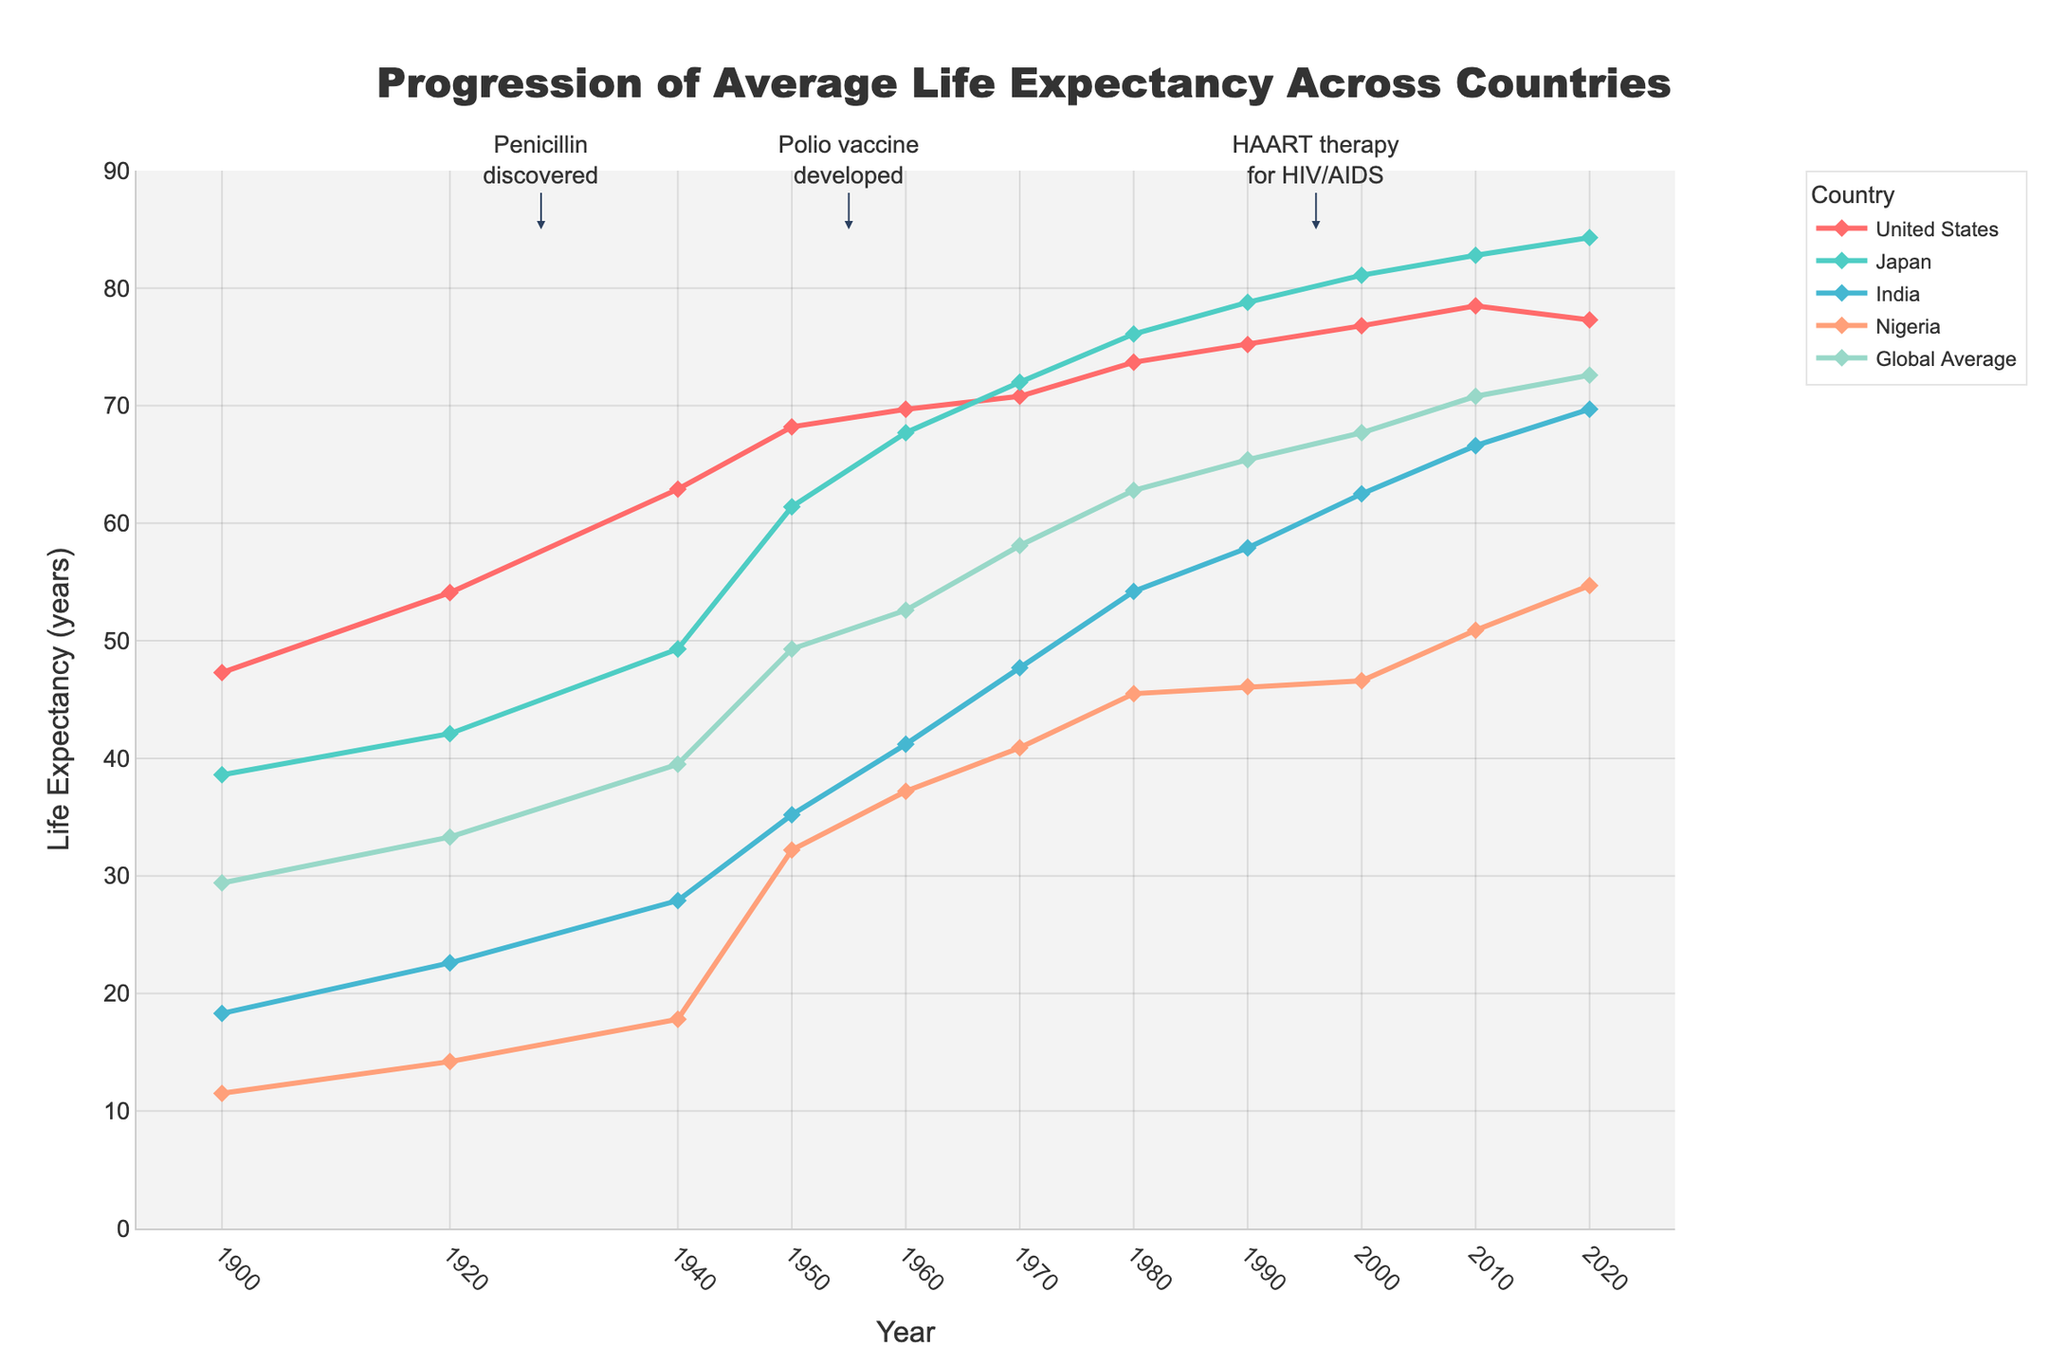What was the global average life expectancy in 1900, and how much did it increase by 2020? The global average life expectancy in 1900 was 29.4 years. By 2020, it increased to 72.6 years. The increase is calculated as 72.6 - 29.4.
Answer: 43.2 years Which country showed the highest life expectancy in 2020, and what was the value? In the year 2020, Japan had the highest life expectancy among the countries listed, which was 84.3 years.
Answer: Japan, 84.3 years Between which consecutive decades did India see the largest increase in life expectancy? By examining the data points for India across decades, we observe the differences in life expectancy: 
(1920: +4.3, 1940: +5.3, 1950: +7.3, 1960: +6.0, 1970: +6.5, 1980: +6.5, 1990: +3.7, 2000: +4.6, 2010: +4.1, 2020: +3.1). 
The largest increase of +8.6 years occurred between 1940 and 1950.
Answer: 1940 to 1950 How does the life expectancy in Nigeria in 1950 compare to the global average in the same year? In 1950, Nigeria's life expectancy was 32.2 years, whereas the global average was 49.3 years. 
To compare, 32.2 is less than 49.3.
Answer: It was lower Which major medical breakthrough is closest to the positive deviation in life expectancy observed in Japan around the 1960-1970 interval? Based on the annotations for major medical breakthroughs, the "Polio vaccine developed" in 1955 is closest to the notable increase in Japan's life expectancy around the 1960-1970 time frame.
Answer: Polio vaccine developed What was the life expectancy in Japan in 1940 and how much has it changed by 1950? The life expectancy in Japan in 1940 was 49.3 years. By 1950, it increased to 61.4 years. The change is calculated as 61.4 - 49.3.
Answer: 12.1 years By what amount did the life expectancy in the United States change from 1900 to 2000? The life expectancy in the United States was 47.3 years in 1900 and increased to 76.8 years in 2000. The change is calculated as 76.8 - 47.3.
Answer: 29.5 years Compare the life expectancy trends of the United States and India from 1980 to 2020. Which country had a steeper increase? From 1980 to 2020, the life expectancy in the United States increased from 73.7 to 77.3 years (an increase of 3.6 years), whereas India's life expectancy increased from 54.2 to 69.7 years (an increase of 15.5 years). Therefore, India had a steeper increase.
Answer: India What color is used to represent India's life expectancy trend line in the plot? The plot used different colors to represent different countries. To identify India, we note that its trend line is colored in light blue.
Answer: Light blue What annotation indicates the discovery of penicillin, and how did this event correlate with the global increase in life expectancy during that period? The annotation for penicillin discovery is marked at the year 1928. Around this period, there is a noticeable upward trend in life expectancy across countries and the global average, indicating a probable positive impact on global health.
Answer: Penicillin discovered, positive correlation 